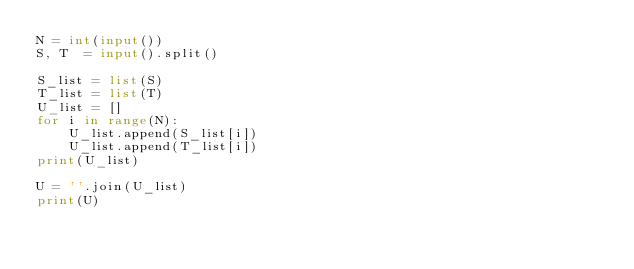Convert code to text. <code><loc_0><loc_0><loc_500><loc_500><_Python_>N = int(input())
S, T  = input().split()

S_list = list(S)
T_list = list(T)
U_list = []
for i in range(N):
    U_list.append(S_list[i])
    U_list.append(T_list[i])
print(U_list)

U = ''.join(U_list)
print(U)</code> 